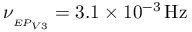Convert formula to latex. <formula><loc_0><loc_0><loc_500><loc_500>\nu _ { _ { E P _ { V 3 } } } = 3 . 1 \times 1 0 ^ { - 3 } \, { H z }</formula> 